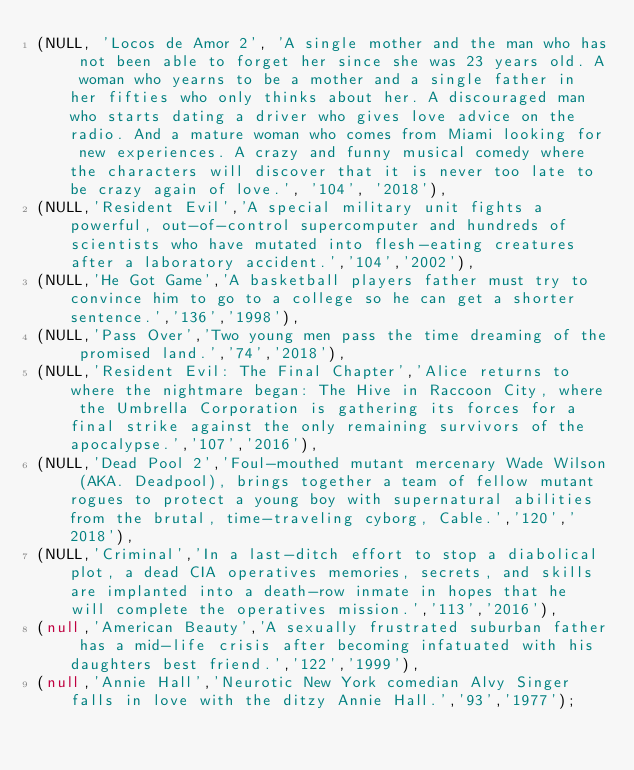<code> <loc_0><loc_0><loc_500><loc_500><_SQL_>(NULL, 'Locos de Amor 2', 'A single mother and the man who has not been able to forget her since she was 23 years old. A woman who yearns to be a mother and a single father in her fifties who only thinks about her. A discouraged man who starts dating a driver who gives love advice on the radio. And a mature woman who comes from Miami looking for new experiences. A crazy and funny musical comedy where the characters will discover that it is never too late to be crazy again of love.', '104', '2018'),
(NULL,'Resident Evil','A special military unit fights a powerful, out-of-control supercomputer and hundreds of scientists who have mutated into flesh-eating creatures after a laboratory accident.','104','2002'),
(NULL,'He Got Game','A basketball players father must try to convince him to go to a college so he can get a shorter sentence.','136','1998'),
(NULL,'Pass Over','Two young men pass the time dreaming of the promised land.','74','2018'),
(NULL,'Resident Evil: The Final Chapter','Alice returns to where the nightmare began: The Hive in Raccoon City, where the Umbrella Corporation is gathering its forces for a final strike against the only remaining survivors of the apocalypse.','107','2016'),
(NULL,'Dead Pool 2','Foul-mouthed mutant mercenary Wade Wilson (AKA. Deadpool), brings together a team of fellow mutant rogues to protect a young boy with supernatural abilities from the brutal, time-traveling cyborg, Cable.','120','2018'),
(NULL,'Criminal','In a last-ditch effort to stop a diabolical plot, a dead CIA operatives memories, secrets, and skills are implanted into a death-row inmate in hopes that he will complete the operatives mission.','113','2016'),
(null,'American Beauty','A sexually frustrated suburban father has a mid-life crisis after becoming infatuated with his daughters best friend.','122','1999'),
(null,'Annie Hall','Neurotic New York comedian Alvy Singer falls in love with the ditzy Annie Hall.','93','1977');</code> 